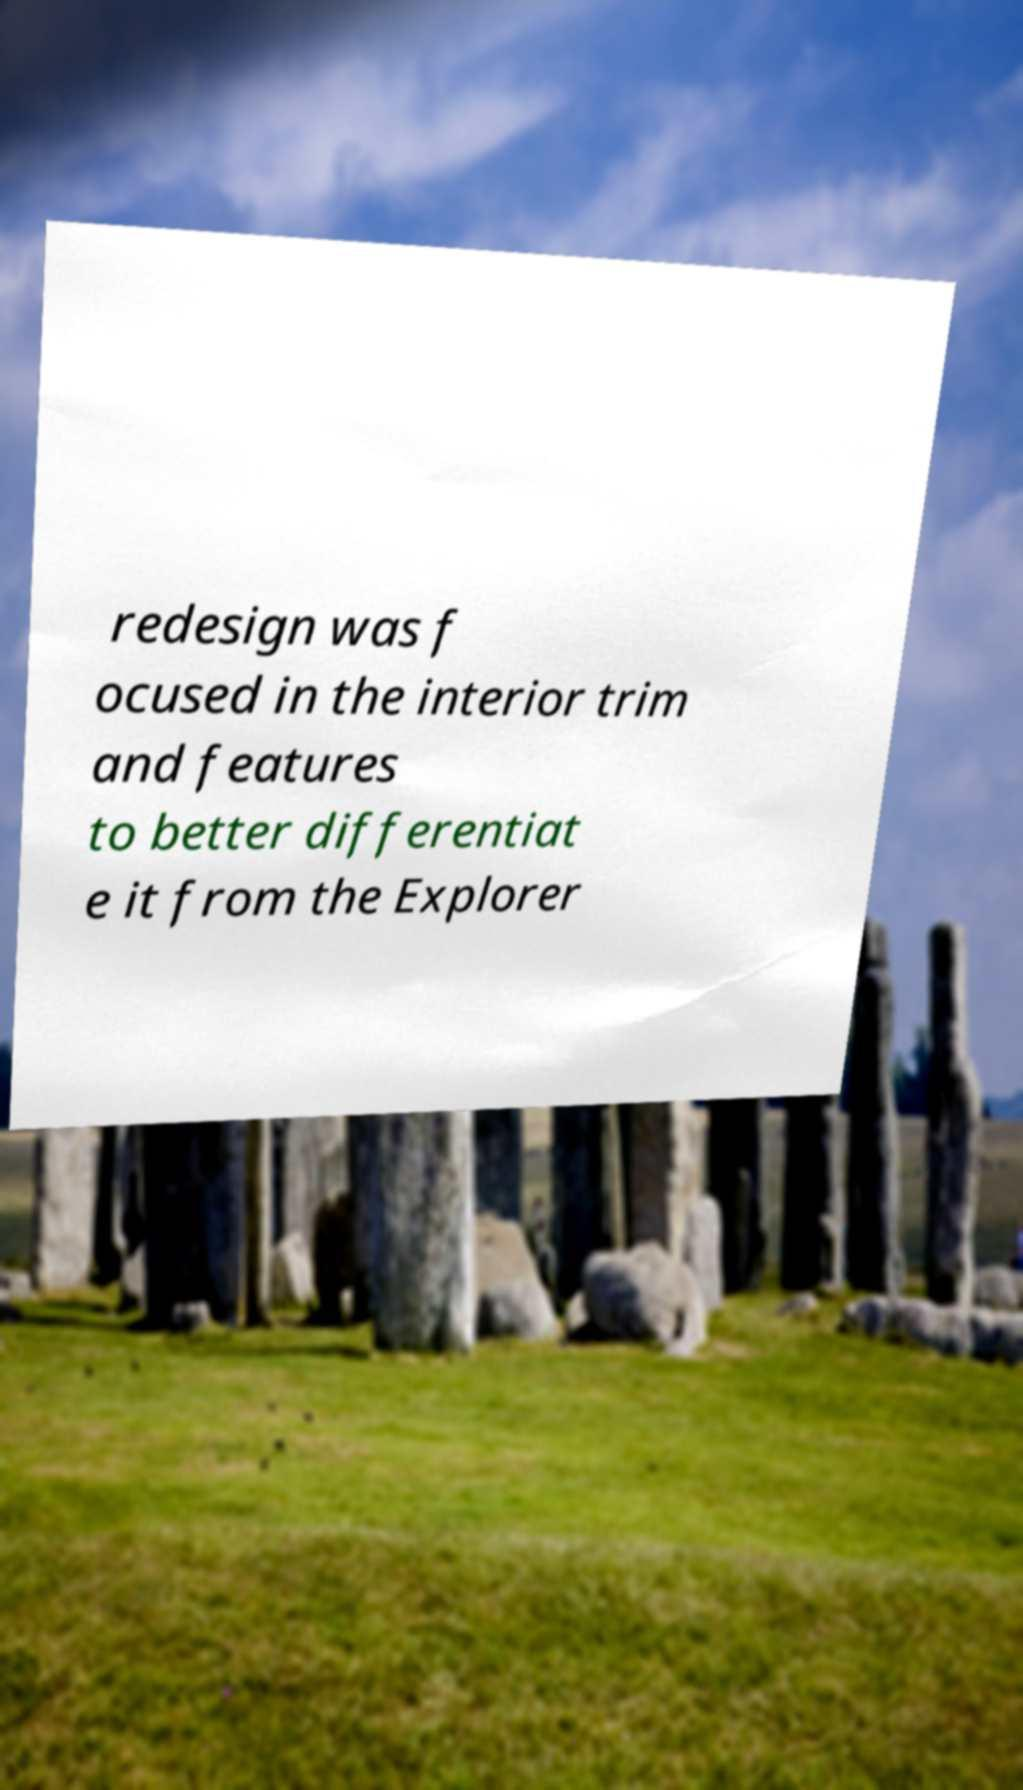For documentation purposes, I need the text within this image transcribed. Could you provide that? redesign was f ocused in the interior trim and features to better differentiat e it from the Explorer 